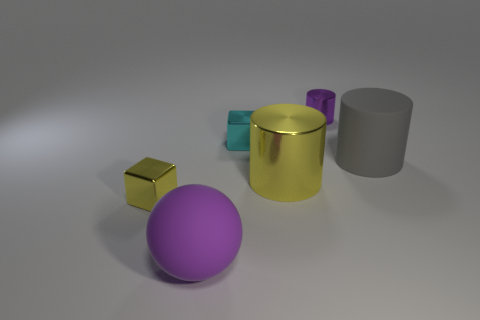Subtract all small purple metal cylinders. How many cylinders are left? 2 Add 1 large yellow metallic cylinders. How many objects exist? 7 Subtract all gray cylinders. How many cylinders are left? 2 Subtract 1 cylinders. How many cylinders are left? 2 Subtract all blocks. How many objects are left? 4 Subtract all large brown shiny things. Subtract all big purple rubber balls. How many objects are left? 5 Add 2 yellow metal objects. How many yellow metal objects are left? 4 Add 6 small green matte cylinders. How many small green matte cylinders exist? 6 Subtract 1 purple spheres. How many objects are left? 5 Subtract all gray balls. Subtract all yellow blocks. How many balls are left? 1 